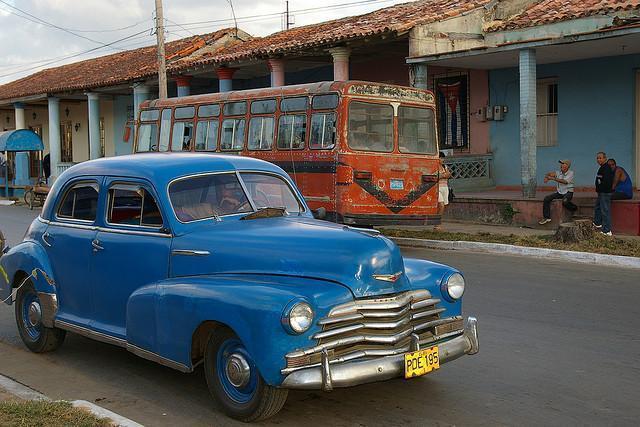Why are the vehicles so old?
Pick the correct solution from the four options below to address the question.
Options: People poor, vintage collectors, cuban embargo, old picture. Cuban embargo. 